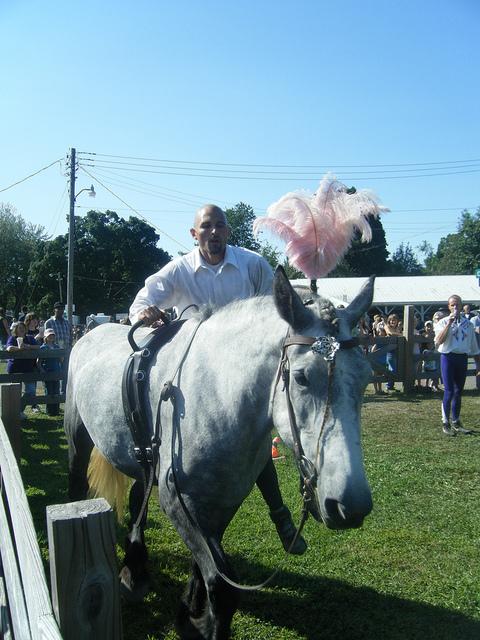Is the sunny outside?
Quick response, please. Yes. Does this animal normally have feathers?
Write a very short answer. No. Which man is hat-less?
Concise answer only. Rider. Is this a horse race?
Answer briefly. No. 